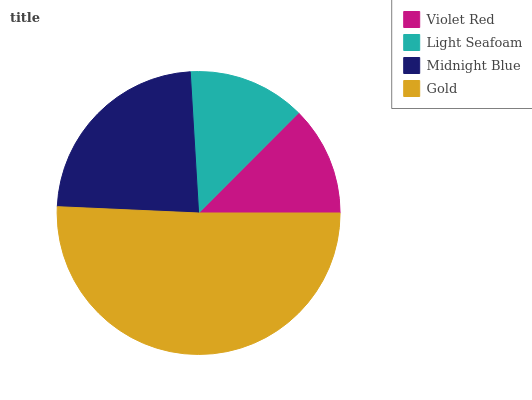Is Violet Red the minimum?
Answer yes or no. Yes. Is Gold the maximum?
Answer yes or no. Yes. Is Light Seafoam the minimum?
Answer yes or no. No. Is Light Seafoam the maximum?
Answer yes or no. No. Is Light Seafoam greater than Violet Red?
Answer yes or no. Yes. Is Violet Red less than Light Seafoam?
Answer yes or no. Yes. Is Violet Red greater than Light Seafoam?
Answer yes or no. No. Is Light Seafoam less than Violet Red?
Answer yes or no. No. Is Midnight Blue the high median?
Answer yes or no. Yes. Is Light Seafoam the low median?
Answer yes or no. Yes. Is Gold the high median?
Answer yes or no. No. Is Violet Red the low median?
Answer yes or no. No. 